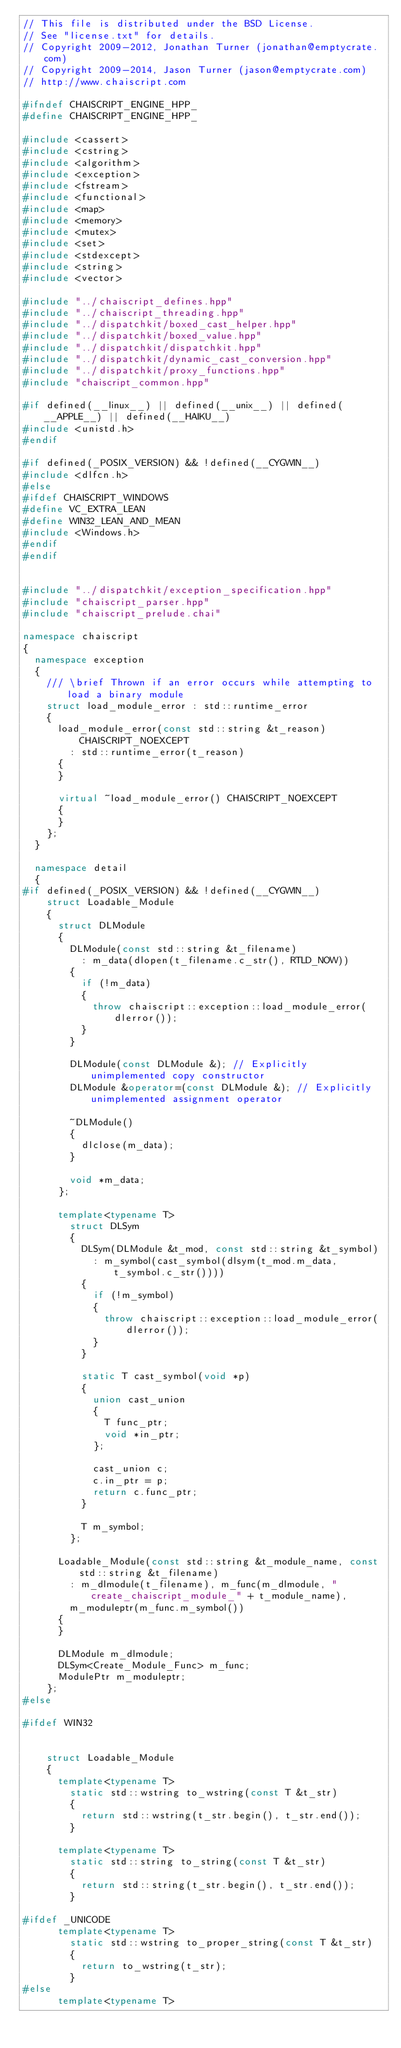Convert code to text. <code><loc_0><loc_0><loc_500><loc_500><_C++_>// This file is distributed under the BSD License.
// See "license.txt" for details.
// Copyright 2009-2012, Jonathan Turner (jonathan@emptycrate.com)
// Copyright 2009-2014, Jason Turner (jason@emptycrate.com)
// http://www.chaiscript.com

#ifndef CHAISCRIPT_ENGINE_HPP_
#define CHAISCRIPT_ENGINE_HPP_

#include <cassert>
#include <cstring>
#include <algorithm>
#include <exception>
#include <fstream>
#include <functional>
#include <map>
#include <memory>
#include <mutex>
#include <set>
#include <stdexcept>
#include <string>
#include <vector>

#include "../chaiscript_defines.hpp"
#include "../chaiscript_threading.hpp"
#include "../dispatchkit/boxed_cast_helper.hpp"
#include "../dispatchkit/boxed_value.hpp"
#include "../dispatchkit/dispatchkit.hpp"
#include "../dispatchkit/dynamic_cast_conversion.hpp"
#include "../dispatchkit/proxy_functions.hpp"
#include "chaiscript_common.hpp"

#if defined(__linux__) || defined(__unix__) || defined(__APPLE__) || defined(__HAIKU__)
#include <unistd.h>
#endif

#if defined(_POSIX_VERSION) && !defined(__CYGWIN__) 
#include <dlfcn.h>
#else
#ifdef CHAISCRIPT_WINDOWS
#define VC_EXTRA_LEAN
#define WIN32_LEAN_AND_MEAN
#include <Windows.h>
#endif
#endif


#include "../dispatchkit/exception_specification.hpp"
#include "chaiscript_parser.hpp"
#include "chaiscript_prelude.chai"

namespace chaiscript
{
  namespace exception
  {
    /// \brief Thrown if an error occurs while attempting to load a binary module
    struct load_module_error : std::runtime_error
    {
      load_module_error(const std::string &t_reason) CHAISCRIPT_NOEXCEPT
        : std::runtime_error(t_reason)
      {
      }

      virtual ~load_module_error() CHAISCRIPT_NOEXCEPT
      {
      }
    };
  }

  namespace detail
  {
#if defined(_POSIX_VERSION) && !defined(__CYGWIN__) 
    struct Loadable_Module
    {
      struct DLModule
      {
        DLModule(const std::string &t_filename)
          : m_data(dlopen(t_filename.c_str(), RTLD_NOW))
        {
          if (!m_data)
          {
            throw chaiscript::exception::load_module_error(dlerror());
          }
        }

        DLModule(const DLModule &); // Explicitly unimplemented copy constructor
        DLModule &operator=(const DLModule &); // Explicitly unimplemented assignment operator

        ~DLModule()
        {
          dlclose(m_data);
        }

        void *m_data;
      };

      template<typename T>
        struct DLSym
        {
          DLSym(DLModule &t_mod, const std::string &t_symbol)
            : m_symbol(cast_symbol(dlsym(t_mod.m_data, t_symbol.c_str())))
          {
            if (!m_symbol)
            {
              throw chaiscript::exception::load_module_error(dlerror());
            }
          }

          static T cast_symbol(void *p)
          {
            union cast_union
            {
              T func_ptr;
              void *in_ptr;
            };

            cast_union c;
            c.in_ptr = p;
            return c.func_ptr;
          }

          T m_symbol;
        };

      Loadable_Module(const std::string &t_module_name, const std::string &t_filename)
        : m_dlmodule(t_filename), m_func(m_dlmodule, "create_chaiscript_module_" + t_module_name),
        m_moduleptr(m_func.m_symbol())
      {
      }

      DLModule m_dlmodule;
      DLSym<Create_Module_Func> m_func;
      ModulePtr m_moduleptr;
    };
#else

#ifdef WIN32


    struct Loadable_Module
    {
      template<typename T>
        static std::wstring to_wstring(const T &t_str) 
        {
          return std::wstring(t_str.begin(), t_str.end());
        }

      template<typename T>
        static std::string to_string(const T &t_str)
        {
          return std::string(t_str.begin(), t_str.end());
        }

#ifdef _UNICODE
      template<typename T>
        static std::wstring to_proper_string(const T &t_str)
        {
          return to_wstring(t_str);
        }
#else
      template<typename T></code> 